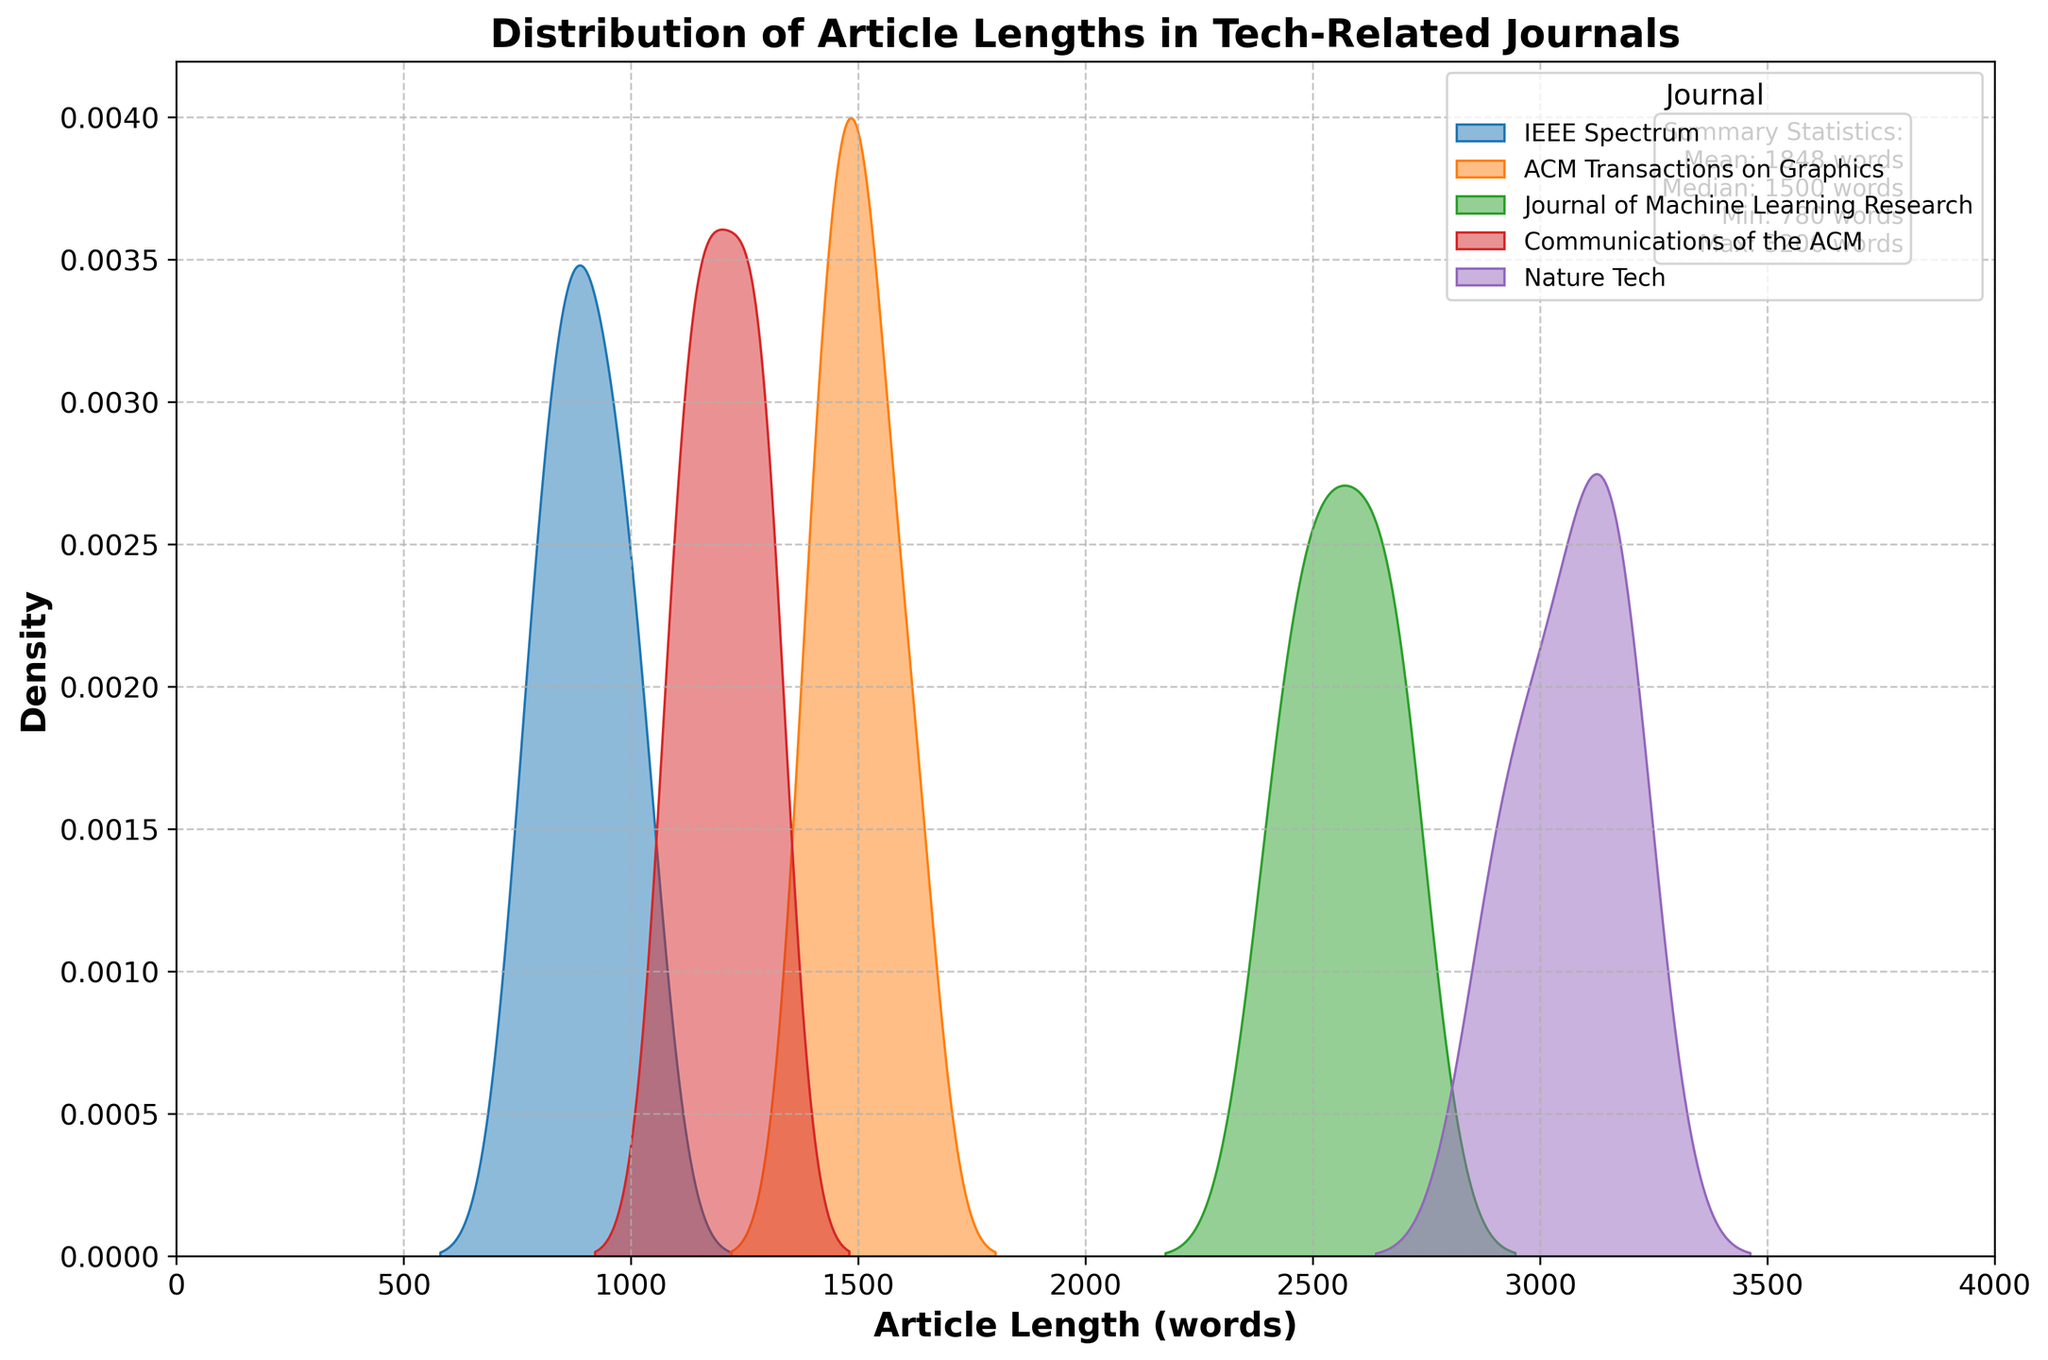What is the title of the plot? The title is displayed at the top and reads: 'Distribution of Article Lengths in Tech-Related Journals'.
Answer: Distribution of Article Lengths in Tech-Related Journals What is the maximum article length shown on the x-axis? The x-axis ranges from 0 to 4000, so the maximum article length is 4000 words.
Answer: 4000 Which journal has the longest articles on average? By looking at the density plot peaks and the summary statistics shown in the text box, Nature Tech articles have consistently higher lengths compared to other journals.
Answer: Nature Tech What does the y-axis represent? The y-axis is labeled "Density," which indicates it represents the density of article lengths within each journal.
Answer: Density How many journals are represented in the density plot? The legend on the top right lists the journals: IEEE Spectrum, ACM Transactions on Graphics, Journal of Machine Learning Research, Communications of the ACM, and Nature Tech, summing up to 5 journals.
Answer: 5 Which journal appears to have the shortest articles? IEEE Spectrum has the shortest articles as observed from its density peak occurring around lower article lengths compared to other journals.
Answer: IEEE Spectrum What are the mean and median values of the article lengths across all journals? The summary statistics text box indicates that the mean is 1780 words and the median is 1450 words.
Answer: Mean: 1780 words, Median: 1450 words Comparing Communications of the ACM and ACM Transactions on Graphics, which one tends to have longer articles? By examining the density plots, ACM Transactions on Graphics tends to have longer articles as its density is concentrated at higher lengths compared to Communications of the ACM.
Answer: ACM Transactions on Graphics What is the minimum and maximum article length among all the journals? The summary statistics text box shows that the minimum article length is 780 words, and the maximum is 3200 words.
Answer: Min: 780 words, Max: 3200 words Which journal has the widest spread of article lengths? Nature Tech shows a wide spread of article lengths as indicated by its flatter and wider density curve compared to the other journals which have sharper peaks.
Answer: Nature Tech 